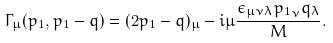<formula> <loc_0><loc_0><loc_500><loc_500>\Gamma _ { \mu } ( p _ { 1 } , p _ { 1 } - q ) = ( 2 p _ { 1 } - q ) _ { \mu } - i \mu { \frac { \epsilon _ { \mu \nu \lambda } { p _ { 1 } } _ { \nu } q _ { \lambda } } { M } } .</formula> 